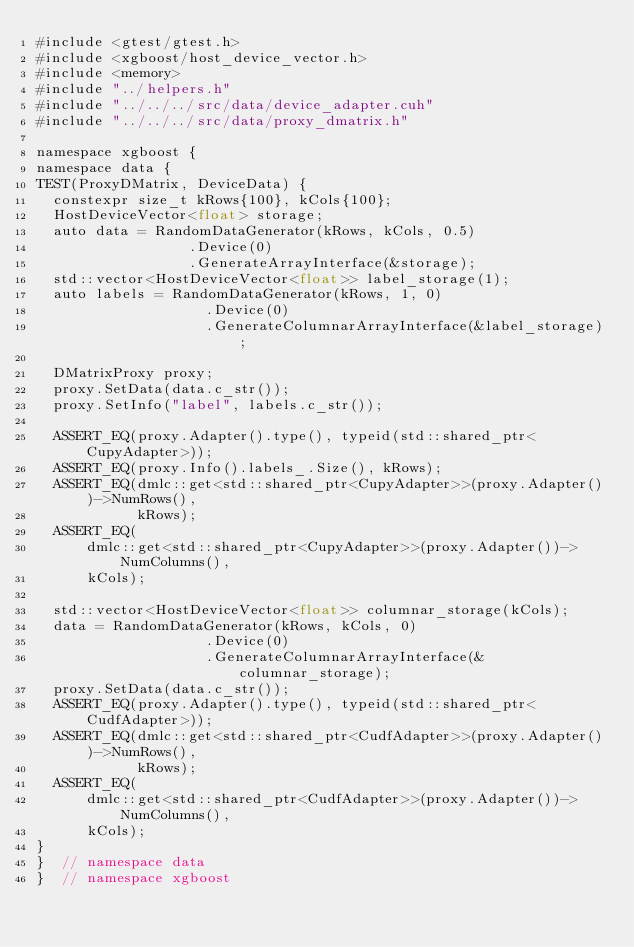<code> <loc_0><loc_0><loc_500><loc_500><_Cuda_>#include <gtest/gtest.h>
#include <xgboost/host_device_vector.h>
#include <memory>
#include "../helpers.h"
#include "../../../src/data/device_adapter.cuh"
#include "../../../src/data/proxy_dmatrix.h"

namespace xgboost {
namespace data {
TEST(ProxyDMatrix, DeviceData) {
  constexpr size_t kRows{100}, kCols{100};
  HostDeviceVector<float> storage;
  auto data = RandomDataGenerator(kRows, kCols, 0.5)
                  .Device(0)
                  .GenerateArrayInterface(&storage);
  std::vector<HostDeviceVector<float>> label_storage(1);
  auto labels = RandomDataGenerator(kRows, 1, 0)
                    .Device(0)
                    .GenerateColumnarArrayInterface(&label_storage);

  DMatrixProxy proxy;
  proxy.SetData(data.c_str());
  proxy.SetInfo("label", labels.c_str());

  ASSERT_EQ(proxy.Adapter().type(), typeid(std::shared_ptr<CupyAdapter>));
  ASSERT_EQ(proxy.Info().labels_.Size(), kRows);
  ASSERT_EQ(dmlc::get<std::shared_ptr<CupyAdapter>>(proxy.Adapter())->NumRows(),
            kRows);
  ASSERT_EQ(
      dmlc::get<std::shared_ptr<CupyAdapter>>(proxy.Adapter())->NumColumns(),
      kCols);

  std::vector<HostDeviceVector<float>> columnar_storage(kCols);
  data = RandomDataGenerator(kRows, kCols, 0)
                    .Device(0)
                    .GenerateColumnarArrayInterface(&columnar_storage);
  proxy.SetData(data.c_str());
  ASSERT_EQ(proxy.Adapter().type(), typeid(std::shared_ptr<CudfAdapter>));
  ASSERT_EQ(dmlc::get<std::shared_ptr<CudfAdapter>>(proxy.Adapter())->NumRows(),
            kRows);
  ASSERT_EQ(
      dmlc::get<std::shared_ptr<CudfAdapter>>(proxy.Adapter())->NumColumns(),
      kCols);
}
}  // namespace data
}  // namespace xgboost
</code> 